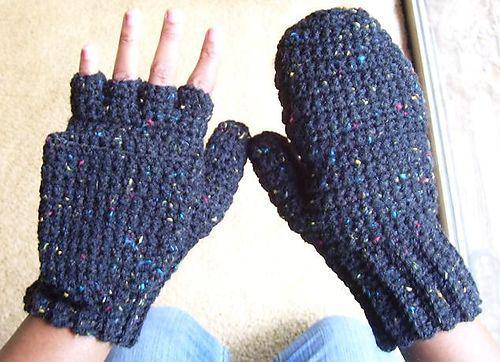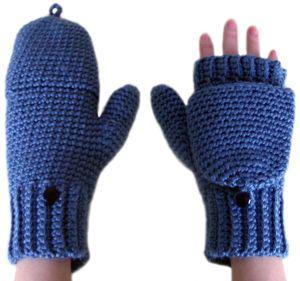The first image is the image on the left, the second image is the image on the right. Examine the images to the left and right. Is the description "One image shows half mittens that leave all fingers exposed and are made of one color of yarn, and the other image contains a half mitten with at least one button." accurate? Answer yes or no. No. 